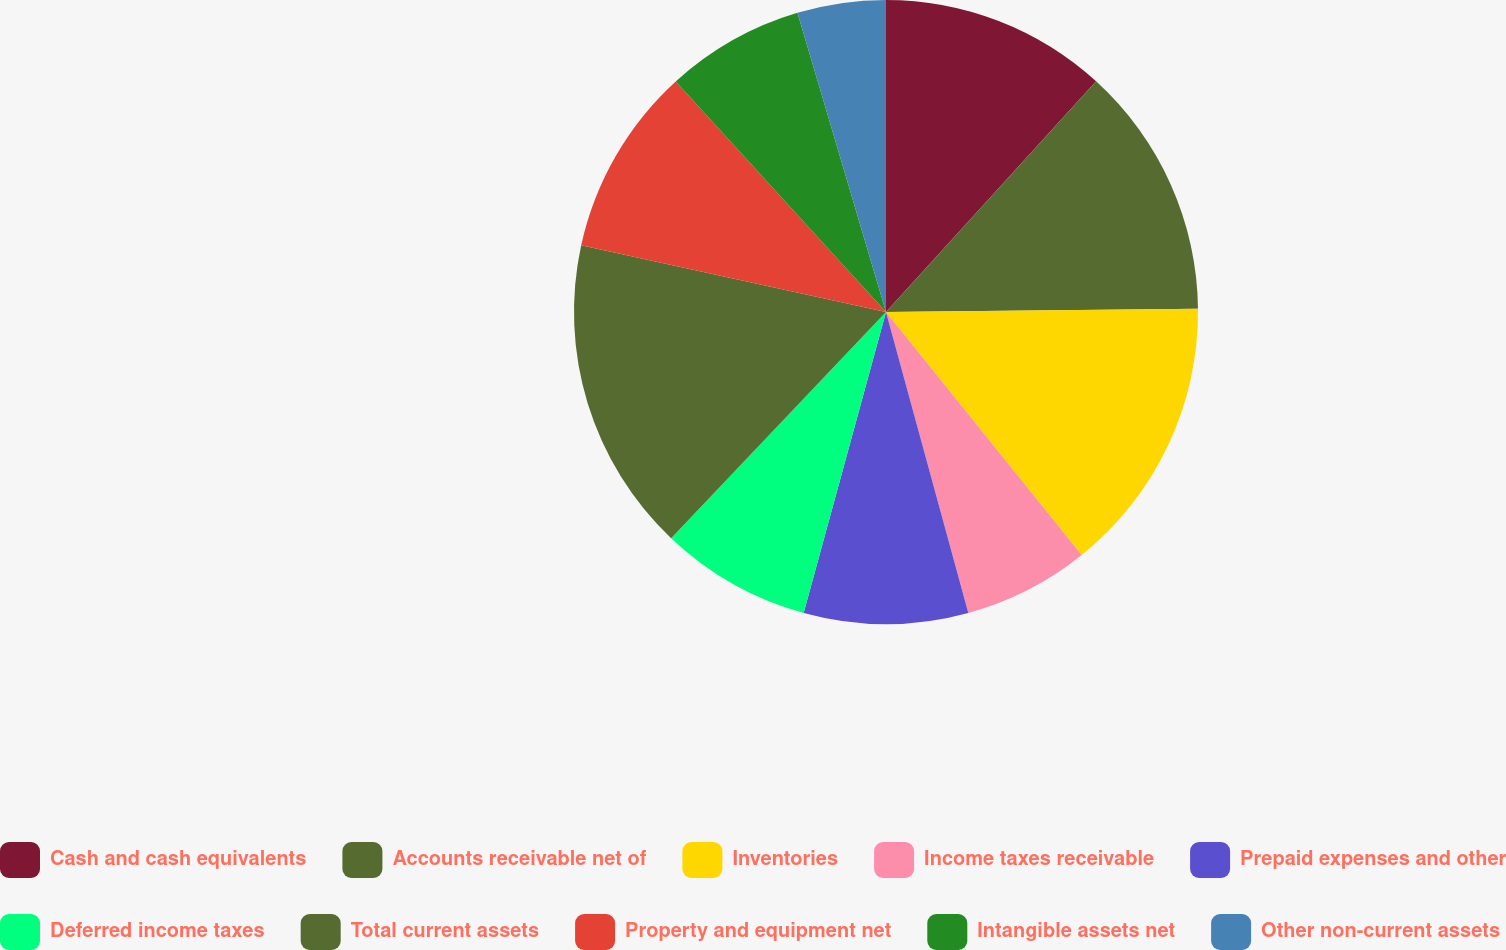<chart> <loc_0><loc_0><loc_500><loc_500><pie_chart><fcel>Cash and cash equivalents<fcel>Accounts receivable net of<fcel>Inventories<fcel>Income taxes receivable<fcel>Prepaid expenses and other<fcel>Deferred income taxes<fcel>Total current assets<fcel>Property and equipment net<fcel>Intangible assets net<fcel>Other non-current assets<nl><fcel>11.76%<fcel>13.07%<fcel>14.38%<fcel>6.54%<fcel>8.5%<fcel>7.84%<fcel>16.34%<fcel>9.8%<fcel>7.19%<fcel>4.58%<nl></chart> 